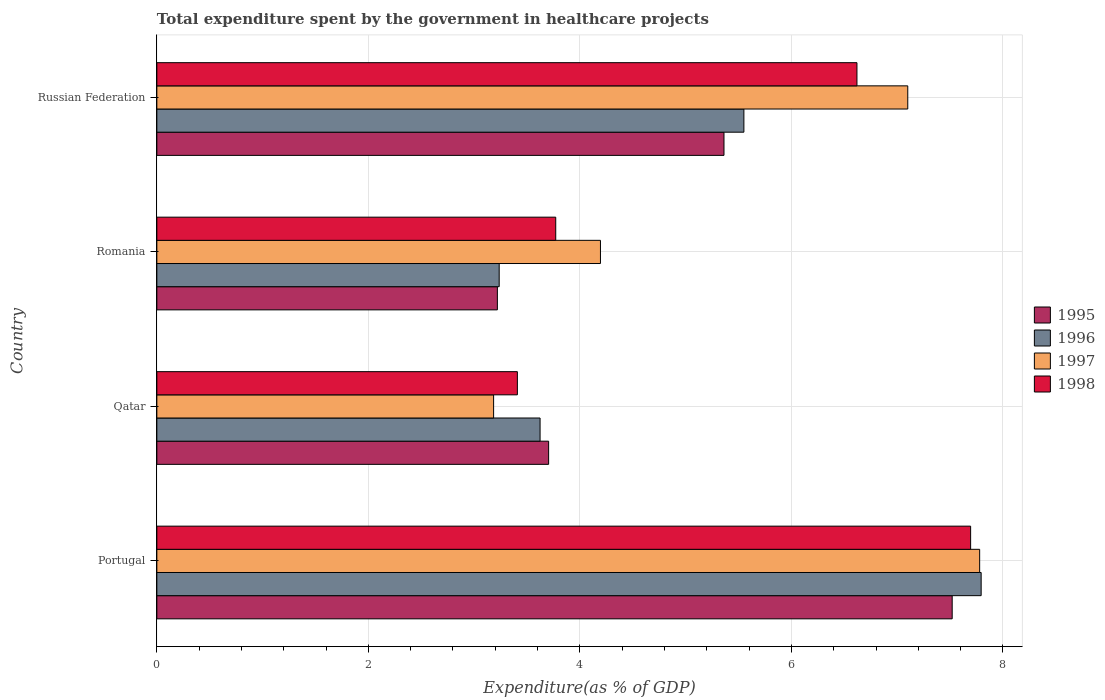How many groups of bars are there?
Ensure brevity in your answer.  4. What is the label of the 1st group of bars from the top?
Your response must be concise. Russian Federation. What is the total expenditure spent by the government in healthcare projects in 1996 in Romania?
Your response must be concise. 3.24. Across all countries, what is the maximum total expenditure spent by the government in healthcare projects in 1996?
Offer a terse response. 7.79. Across all countries, what is the minimum total expenditure spent by the government in healthcare projects in 1998?
Your response must be concise. 3.41. In which country was the total expenditure spent by the government in healthcare projects in 1998 maximum?
Your answer should be very brief. Portugal. In which country was the total expenditure spent by the government in healthcare projects in 1995 minimum?
Offer a very short reply. Romania. What is the total total expenditure spent by the government in healthcare projects in 1998 in the graph?
Give a very brief answer. 21.5. What is the difference between the total expenditure spent by the government in healthcare projects in 1996 in Portugal and that in Russian Federation?
Offer a terse response. 2.24. What is the difference between the total expenditure spent by the government in healthcare projects in 1998 in Russian Federation and the total expenditure spent by the government in healthcare projects in 1995 in Qatar?
Offer a terse response. 2.92. What is the average total expenditure spent by the government in healthcare projects in 1995 per country?
Provide a succinct answer. 4.95. What is the difference between the total expenditure spent by the government in healthcare projects in 1996 and total expenditure spent by the government in healthcare projects in 1995 in Russian Federation?
Your answer should be very brief. 0.19. What is the ratio of the total expenditure spent by the government in healthcare projects in 1996 in Portugal to that in Romania?
Your response must be concise. 2.41. Is the total expenditure spent by the government in healthcare projects in 1997 in Portugal less than that in Qatar?
Make the answer very short. No. What is the difference between the highest and the second highest total expenditure spent by the government in healthcare projects in 1996?
Provide a succinct answer. 2.24. What is the difference between the highest and the lowest total expenditure spent by the government in healthcare projects in 1996?
Keep it short and to the point. 4.56. In how many countries, is the total expenditure spent by the government in healthcare projects in 1997 greater than the average total expenditure spent by the government in healthcare projects in 1997 taken over all countries?
Offer a terse response. 2. What does the 1st bar from the bottom in Qatar represents?
Offer a terse response. 1995. Is it the case that in every country, the sum of the total expenditure spent by the government in healthcare projects in 1995 and total expenditure spent by the government in healthcare projects in 1997 is greater than the total expenditure spent by the government in healthcare projects in 1998?
Provide a short and direct response. Yes. How many bars are there?
Make the answer very short. 16. How many countries are there in the graph?
Ensure brevity in your answer.  4. Does the graph contain any zero values?
Provide a succinct answer. No. How are the legend labels stacked?
Your answer should be very brief. Vertical. What is the title of the graph?
Give a very brief answer. Total expenditure spent by the government in healthcare projects. What is the label or title of the X-axis?
Provide a short and direct response. Expenditure(as % of GDP). What is the label or title of the Y-axis?
Ensure brevity in your answer.  Country. What is the Expenditure(as % of GDP) of 1995 in Portugal?
Offer a terse response. 7.52. What is the Expenditure(as % of GDP) in 1996 in Portugal?
Offer a terse response. 7.79. What is the Expenditure(as % of GDP) in 1997 in Portugal?
Make the answer very short. 7.78. What is the Expenditure(as % of GDP) of 1998 in Portugal?
Offer a terse response. 7.69. What is the Expenditure(as % of GDP) of 1995 in Qatar?
Your answer should be very brief. 3.7. What is the Expenditure(as % of GDP) of 1996 in Qatar?
Offer a very short reply. 3.62. What is the Expenditure(as % of GDP) in 1997 in Qatar?
Offer a terse response. 3.18. What is the Expenditure(as % of GDP) in 1998 in Qatar?
Your answer should be compact. 3.41. What is the Expenditure(as % of GDP) of 1995 in Romania?
Offer a very short reply. 3.22. What is the Expenditure(as % of GDP) of 1996 in Romania?
Ensure brevity in your answer.  3.24. What is the Expenditure(as % of GDP) of 1997 in Romania?
Your response must be concise. 4.19. What is the Expenditure(as % of GDP) of 1998 in Romania?
Provide a short and direct response. 3.77. What is the Expenditure(as % of GDP) of 1995 in Russian Federation?
Offer a terse response. 5.36. What is the Expenditure(as % of GDP) of 1996 in Russian Federation?
Make the answer very short. 5.55. What is the Expenditure(as % of GDP) of 1997 in Russian Federation?
Provide a succinct answer. 7.1. What is the Expenditure(as % of GDP) of 1998 in Russian Federation?
Keep it short and to the point. 6.62. Across all countries, what is the maximum Expenditure(as % of GDP) of 1995?
Make the answer very short. 7.52. Across all countries, what is the maximum Expenditure(as % of GDP) of 1996?
Offer a terse response. 7.79. Across all countries, what is the maximum Expenditure(as % of GDP) in 1997?
Your response must be concise. 7.78. Across all countries, what is the maximum Expenditure(as % of GDP) of 1998?
Offer a very short reply. 7.69. Across all countries, what is the minimum Expenditure(as % of GDP) in 1995?
Your answer should be very brief. 3.22. Across all countries, what is the minimum Expenditure(as % of GDP) in 1996?
Ensure brevity in your answer.  3.24. Across all countries, what is the minimum Expenditure(as % of GDP) of 1997?
Your response must be concise. 3.18. Across all countries, what is the minimum Expenditure(as % of GDP) of 1998?
Your answer should be compact. 3.41. What is the total Expenditure(as % of GDP) of 1995 in the graph?
Your answer should be compact. 19.81. What is the total Expenditure(as % of GDP) in 1996 in the graph?
Offer a terse response. 20.21. What is the total Expenditure(as % of GDP) of 1997 in the graph?
Offer a very short reply. 22.26. What is the total Expenditure(as % of GDP) in 1998 in the graph?
Offer a very short reply. 21.5. What is the difference between the Expenditure(as % of GDP) in 1995 in Portugal and that in Qatar?
Offer a very short reply. 3.82. What is the difference between the Expenditure(as % of GDP) in 1996 in Portugal and that in Qatar?
Your answer should be compact. 4.17. What is the difference between the Expenditure(as % of GDP) of 1997 in Portugal and that in Qatar?
Your answer should be very brief. 4.6. What is the difference between the Expenditure(as % of GDP) of 1998 in Portugal and that in Qatar?
Offer a very short reply. 4.29. What is the difference between the Expenditure(as % of GDP) of 1995 in Portugal and that in Romania?
Your answer should be compact. 4.3. What is the difference between the Expenditure(as % of GDP) in 1996 in Portugal and that in Romania?
Offer a very short reply. 4.56. What is the difference between the Expenditure(as % of GDP) of 1997 in Portugal and that in Romania?
Your response must be concise. 3.59. What is the difference between the Expenditure(as % of GDP) of 1998 in Portugal and that in Romania?
Make the answer very short. 3.92. What is the difference between the Expenditure(as % of GDP) of 1995 in Portugal and that in Russian Federation?
Give a very brief answer. 2.16. What is the difference between the Expenditure(as % of GDP) in 1996 in Portugal and that in Russian Federation?
Keep it short and to the point. 2.24. What is the difference between the Expenditure(as % of GDP) of 1997 in Portugal and that in Russian Federation?
Give a very brief answer. 0.68. What is the difference between the Expenditure(as % of GDP) of 1998 in Portugal and that in Russian Federation?
Offer a terse response. 1.07. What is the difference between the Expenditure(as % of GDP) of 1995 in Qatar and that in Romania?
Your response must be concise. 0.48. What is the difference between the Expenditure(as % of GDP) of 1996 in Qatar and that in Romania?
Your response must be concise. 0.39. What is the difference between the Expenditure(as % of GDP) of 1997 in Qatar and that in Romania?
Give a very brief answer. -1.01. What is the difference between the Expenditure(as % of GDP) in 1998 in Qatar and that in Romania?
Keep it short and to the point. -0.36. What is the difference between the Expenditure(as % of GDP) of 1995 in Qatar and that in Russian Federation?
Keep it short and to the point. -1.66. What is the difference between the Expenditure(as % of GDP) in 1996 in Qatar and that in Russian Federation?
Make the answer very short. -1.93. What is the difference between the Expenditure(as % of GDP) in 1997 in Qatar and that in Russian Federation?
Offer a terse response. -3.92. What is the difference between the Expenditure(as % of GDP) in 1998 in Qatar and that in Russian Federation?
Offer a terse response. -3.21. What is the difference between the Expenditure(as % of GDP) in 1995 in Romania and that in Russian Federation?
Your response must be concise. -2.14. What is the difference between the Expenditure(as % of GDP) in 1996 in Romania and that in Russian Federation?
Your response must be concise. -2.31. What is the difference between the Expenditure(as % of GDP) in 1997 in Romania and that in Russian Federation?
Provide a short and direct response. -2.91. What is the difference between the Expenditure(as % of GDP) of 1998 in Romania and that in Russian Federation?
Your answer should be very brief. -2.85. What is the difference between the Expenditure(as % of GDP) in 1995 in Portugal and the Expenditure(as % of GDP) in 1996 in Qatar?
Provide a succinct answer. 3.9. What is the difference between the Expenditure(as % of GDP) of 1995 in Portugal and the Expenditure(as % of GDP) of 1997 in Qatar?
Ensure brevity in your answer.  4.34. What is the difference between the Expenditure(as % of GDP) of 1995 in Portugal and the Expenditure(as % of GDP) of 1998 in Qatar?
Offer a very short reply. 4.11. What is the difference between the Expenditure(as % of GDP) in 1996 in Portugal and the Expenditure(as % of GDP) in 1997 in Qatar?
Your answer should be very brief. 4.61. What is the difference between the Expenditure(as % of GDP) of 1996 in Portugal and the Expenditure(as % of GDP) of 1998 in Qatar?
Provide a succinct answer. 4.39. What is the difference between the Expenditure(as % of GDP) in 1997 in Portugal and the Expenditure(as % of GDP) in 1998 in Qatar?
Your response must be concise. 4.37. What is the difference between the Expenditure(as % of GDP) in 1995 in Portugal and the Expenditure(as % of GDP) in 1996 in Romania?
Ensure brevity in your answer.  4.28. What is the difference between the Expenditure(as % of GDP) of 1995 in Portugal and the Expenditure(as % of GDP) of 1997 in Romania?
Your answer should be very brief. 3.33. What is the difference between the Expenditure(as % of GDP) in 1995 in Portugal and the Expenditure(as % of GDP) in 1998 in Romania?
Provide a succinct answer. 3.75. What is the difference between the Expenditure(as % of GDP) in 1996 in Portugal and the Expenditure(as % of GDP) in 1997 in Romania?
Your response must be concise. 3.6. What is the difference between the Expenditure(as % of GDP) in 1996 in Portugal and the Expenditure(as % of GDP) in 1998 in Romania?
Make the answer very short. 4.02. What is the difference between the Expenditure(as % of GDP) in 1997 in Portugal and the Expenditure(as % of GDP) in 1998 in Romania?
Keep it short and to the point. 4.01. What is the difference between the Expenditure(as % of GDP) of 1995 in Portugal and the Expenditure(as % of GDP) of 1996 in Russian Federation?
Keep it short and to the point. 1.97. What is the difference between the Expenditure(as % of GDP) of 1995 in Portugal and the Expenditure(as % of GDP) of 1997 in Russian Federation?
Ensure brevity in your answer.  0.42. What is the difference between the Expenditure(as % of GDP) of 1995 in Portugal and the Expenditure(as % of GDP) of 1998 in Russian Federation?
Ensure brevity in your answer.  0.9. What is the difference between the Expenditure(as % of GDP) of 1996 in Portugal and the Expenditure(as % of GDP) of 1997 in Russian Federation?
Your answer should be very brief. 0.69. What is the difference between the Expenditure(as % of GDP) of 1996 in Portugal and the Expenditure(as % of GDP) of 1998 in Russian Federation?
Provide a succinct answer. 1.17. What is the difference between the Expenditure(as % of GDP) of 1997 in Portugal and the Expenditure(as % of GDP) of 1998 in Russian Federation?
Make the answer very short. 1.16. What is the difference between the Expenditure(as % of GDP) of 1995 in Qatar and the Expenditure(as % of GDP) of 1996 in Romania?
Provide a short and direct response. 0.47. What is the difference between the Expenditure(as % of GDP) in 1995 in Qatar and the Expenditure(as % of GDP) in 1997 in Romania?
Your response must be concise. -0.49. What is the difference between the Expenditure(as % of GDP) in 1995 in Qatar and the Expenditure(as % of GDP) in 1998 in Romania?
Give a very brief answer. -0.07. What is the difference between the Expenditure(as % of GDP) in 1996 in Qatar and the Expenditure(as % of GDP) in 1997 in Romania?
Offer a very short reply. -0.57. What is the difference between the Expenditure(as % of GDP) of 1996 in Qatar and the Expenditure(as % of GDP) of 1998 in Romania?
Provide a short and direct response. -0.15. What is the difference between the Expenditure(as % of GDP) in 1997 in Qatar and the Expenditure(as % of GDP) in 1998 in Romania?
Your answer should be very brief. -0.59. What is the difference between the Expenditure(as % of GDP) in 1995 in Qatar and the Expenditure(as % of GDP) in 1996 in Russian Federation?
Give a very brief answer. -1.85. What is the difference between the Expenditure(as % of GDP) of 1995 in Qatar and the Expenditure(as % of GDP) of 1997 in Russian Federation?
Keep it short and to the point. -3.4. What is the difference between the Expenditure(as % of GDP) in 1995 in Qatar and the Expenditure(as % of GDP) in 1998 in Russian Federation?
Ensure brevity in your answer.  -2.92. What is the difference between the Expenditure(as % of GDP) of 1996 in Qatar and the Expenditure(as % of GDP) of 1997 in Russian Federation?
Make the answer very short. -3.48. What is the difference between the Expenditure(as % of GDP) in 1996 in Qatar and the Expenditure(as % of GDP) in 1998 in Russian Federation?
Ensure brevity in your answer.  -3. What is the difference between the Expenditure(as % of GDP) of 1997 in Qatar and the Expenditure(as % of GDP) of 1998 in Russian Federation?
Offer a very short reply. -3.44. What is the difference between the Expenditure(as % of GDP) in 1995 in Romania and the Expenditure(as % of GDP) in 1996 in Russian Federation?
Offer a terse response. -2.33. What is the difference between the Expenditure(as % of GDP) in 1995 in Romania and the Expenditure(as % of GDP) in 1997 in Russian Federation?
Give a very brief answer. -3.88. What is the difference between the Expenditure(as % of GDP) of 1995 in Romania and the Expenditure(as % of GDP) of 1998 in Russian Federation?
Keep it short and to the point. -3.4. What is the difference between the Expenditure(as % of GDP) of 1996 in Romania and the Expenditure(as % of GDP) of 1997 in Russian Federation?
Offer a very short reply. -3.86. What is the difference between the Expenditure(as % of GDP) in 1996 in Romania and the Expenditure(as % of GDP) in 1998 in Russian Federation?
Your response must be concise. -3.38. What is the difference between the Expenditure(as % of GDP) of 1997 in Romania and the Expenditure(as % of GDP) of 1998 in Russian Federation?
Offer a terse response. -2.43. What is the average Expenditure(as % of GDP) of 1995 per country?
Ensure brevity in your answer.  4.95. What is the average Expenditure(as % of GDP) of 1996 per country?
Your response must be concise. 5.05. What is the average Expenditure(as % of GDP) in 1997 per country?
Offer a terse response. 5.56. What is the average Expenditure(as % of GDP) in 1998 per country?
Ensure brevity in your answer.  5.37. What is the difference between the Expenditure(as % of GDP) of 1995 and Expenditure(as % of GDP) of 1996 in Portugal?
Offer a terse response. -0.27. What is the difference between the Expenditure(as % of GDP) of 1995 and Expenditure(as % of GDP) of 1997 in Portugal?
Your answer should be very brief. -0.26. What is the difference between the Expenditure(as % of GDP) of 1995 and Expenditure(as % of GDP) of 1998 in Portugal?
Give a very brief answer. -0.17. What is the difference between the Expenditure(as % of GDP) in 1996 and Expenditure(as % of GDP) in 1997 in Portugal?
Make the answer very short. 0.01. What is the difference between the Expenditure(as % of GDP) in 1996 and Expenditure(as % of GDP) in 1998 in Portugal?
Keep it short and to the point. 0.1. What is the difference between the Expenditure(as % of GDP) in 1997 and Expenditure(as % of GDP) in 1998 in Portugal?
Provide a short and direct response. 0.09. What is the difference between the Expenditure(as % of GDP) in 1995 and Expenditure(as % of GDP) in 1996 in Qatar?
Provide a succinct answer. 0.08. What is the difference between the Expenditure(as % of GDP) of 1995 and Expenditure(as % of GDP) of 1997 in Qatar?
Give a very brief answer. 0.52. What is the difference between the Expenditure(as % of GDP) of 1995 and Expenditure(as % of GDP) of 1998 in Qatar?
Your answer should be very brief. 0.3. What is the difference between the Expenditure(as % of GDP) of 1996 and Expenditure(as % of GDP) of 1997 in Qatar?
Offer a very short reply. 0.44. What is the difference between the Expenditure(as % of GDP) in 1996 and Expenditure(as % of GDP) in 1998 in Qatar?
Offer a very short reply. 0.21. What is the difference between the Expenditure(as % of GDP) of 1997 and Expenditure(as % of GDP) of 1998 in Qatar?
Make the answer very short. -0.22. What is the difference between the Expenditure(as % of GDP) of 1995 and Expenditure(as % of GDP) of 1996 in Romania?
Make the answer very short. -0.02. What is the difference between the Expenditure(as % of GDP) of 1995 and Expenditure(as % of GDP) of 1997 in Romania?
Provide a short and direct response. -0.97. What is the difference between the Expenditure(as % of GDP) in 1995 and Expenditure(as % of GDP) in 1998 in Romania?
Your answer should be compact. -0.55. What is the difference between the Expenditure(as % of GDP) in 1996 and Expenditure(as % of GDP) in 1997 in Romania?
Provide a short and direct response. -0.96. What is the difference between the Expenditure(as % of GDP) in 1996 and Expenditure(as % of GDP) in 1998 in Romania?
Ensure brevity in your answer.  -0.53. What is the difference between the Expenditure(as % of GDP) of 1997 and Expenditure(as % of GDP) of 1998 in Romania?
Offer a very short reply. 0.42. What is the difference between the Expenditure(as % of GDP) in 1995 and Expenditure(as % of GDP) in 1996 in Russian Federation?
Offer a terse response. -0.19. What is the difference between the Expenditure(as % of GDP) in 1995 and Expenditure(as % of GDP) in 1997 in Russian Federation?
Keep it short and to the point. -1.74. What is the difference between the Expenditure(as % of GDP) in 1995 and Expenditure(as % of GDP) in 1998 in Russian Federation?
Keep it short and to the point. -1.26. What is the difference between the Expenditure(as % of GDP) in 1996 and Expenditure(as % of GDP) in 1997 in Russian Federation?
Provide a succinct answer. -1.55. What is the difference between the Expenditure(as % of GDP) of 1996 and Expenditure(as % of GDP) of 1998 in Russian Federation?
Your response must be concise. -1.07. What is the difference between the Expenditure(as % of GDP) in 1997 and Expenditure(as % of GDP) in 1998 in Russian Federation?
Keep it short and to the point. 0.48. What is the ratio of the Expenditure(as % of GDP) of 1995 in Portugal to that in Qatar?
Keep it short and to the point. 2.03. What is the ratio of the Expenditure(as % of GDP) in 1996 in Portugal to that in Qatar?
Your answer should be compact. 2.15. What is the ratio of the Expenditure(as % of GDP) of 1997 in Portugal to that in Qatar?
Your answer should be compact. 2.44. What is the ratio of the Expenditure(as % of GDP) of 1998 in Portugal to that in Qatar?
Your answer should be compact. 2.26. What is the ratio of the Expenditure(as % of GDP) in 1995 in Portugal to that in Romania?
Your answer should be compact. 2.34. What is the ratio of the Expenditure(as % of GDP) in 1996 in Portugal to that in Romania?
Provide a succinct answer. 2.41. What is the ratio of the Expenditure(as % of GDP) in 1997 in Portugal to that in Romania?
Offer a very short reply. 1.85. What is the ratio of the Expenditure(as % of GDP) in 1998 in Portugal to that in Romania?
Offer a terse response. 2.04. What is the ratio of the Expenditure(as % of GDP) of 1995 in Portugal to that in Russian Federation?
Your response must be concise. 1.4. What is the ratio of the Expenditure(as % of GDP) in 1996 in Portugal to that in Russian Federation?
Offer a very short reply. 1.4. What is the ratio of the Expenditure(as % of GDP) of 1997 in Portugal to that in Russian Federation?
Your answer should be compact. 1.1. What is the ratio of the Expenditure(as % of GDP) of 1998 in Portugal to that in Russian Federation?
Give a very brief answer. 1.16. What is the ratio of the Expenditure(as % of GDP) in 1995 in Qatar to that in Romania?
Your answer should be very brief. 1.15. What is the ratio of the Expenditure(as % of GDP) of 1996 in Qatar to that in Romania?
Give a very brief answer. 1.12. What is the ratio of the Expenditure(as % of GDP) in 1997 in Qatar to that in Romania?
Give a very brief answer. 0.76. What is the ratio of the Expenditure(as % of GDP) of 1998 in Qatar to that in Romania?
Your answer should be very brief. 0.9. What is the ratio of the Expenditure(as % of GDP) in 1995 in Qatar to that in Russian Federation?
Provide a short and direct response. 0.69. What is the ratio of the Expenditure(as % of GDP) in 1996 in Qatar to that in Russian Federation?
Give a very brief answer. 0.65. What is the ratio of the Expenditure(as % of GDP) in 1997 in Qatar to that in Russian Federation?
Give a very brief answer. 0.45. What is the ratio of the Expenditure(as % of GDP) in 1998 in Qatar to that in Russian Federation?
Offer a very short reply. 0.52. What is the ratio of the Expenditure(as % of GDP) in 1995 in Romania to that in Russian Federation?
Offer a terse response. 0.6. What is the ratio of the Expenditure(as % of GDP) in 1996 in Romania to that in Russian Federation?
Give a very brief answer. 0.58. What is the ratio of the Expenditure(as % of GDP) of 1997 in Romania to that in Russian Federation?
Give a very brief answer. 0.59. What is the ratio of the Expenditure(as % of GDP) of 1998 in Romania to that in Russian Federation?
Your answer should be compact. 0.57. What is the difference between the highest and the second highest Expenditure(as % of GDP) of 1995?
Provide a short and direct response. 2.16. What is the difference between the highest and the second highest Expenditure(as % of GDP) of 1996?
Provide a short and direct response. 2.24. What is the difference between the highest and the second highest Expenditure(as % of GDP) in 1997?
Your response must be concise. 0.68. What is the difference between the highest and the second highest Expenditure(as % of GDP) of 1998?
Ensure brevity in your answer.  1.07. What is the difference between the highest and the lowest Expenditure(as % of GDP) of 1995?
Provide a short and direct response. 4.3. What is the difference between the highest and the lowest Expenditure(as % of GDP) in 1996?
Make the answer very short. 4.56. What is the difference between the highest and the lowest Expenditure(as % of GDP) in 1997?
Provide a short and direct response. 4.6. What is the difference between the highest and the lowest Expenditure(as % of GDP) of 1998?
Keep it short and to the point. 4.29. 